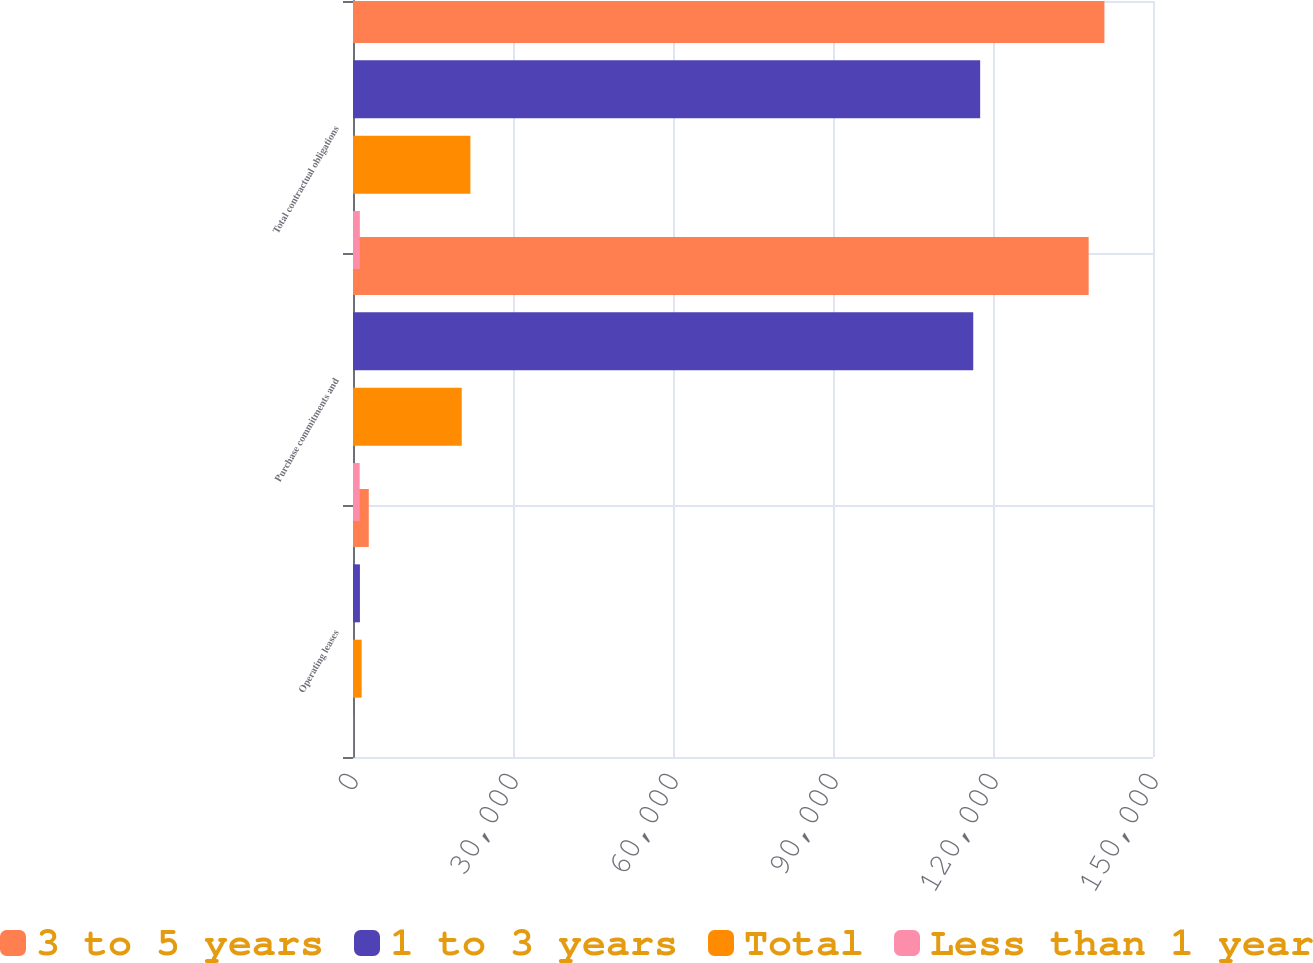Convert chart to OTSL. <chart><loc_0><loc_0><loc_500><loc_500><stacked_bar_chart><ecel><fcel>Operating leases<fcel>Purchase commitments and<fcel>Total contractual obligations<nl><fcel>3 to 5 years<fcel>2956<fcel>137936<fcel>140892<nl><fcel>1 to 3 years<fcel>1298<fcel>116295<fcel>117593<nl><fcel>Total<fcel>1622<fcel>20391<fcel>22013<nl><fcel>Less than 1 year<fcel>36<fcel>1250<fcel>1286<nl></chart> 